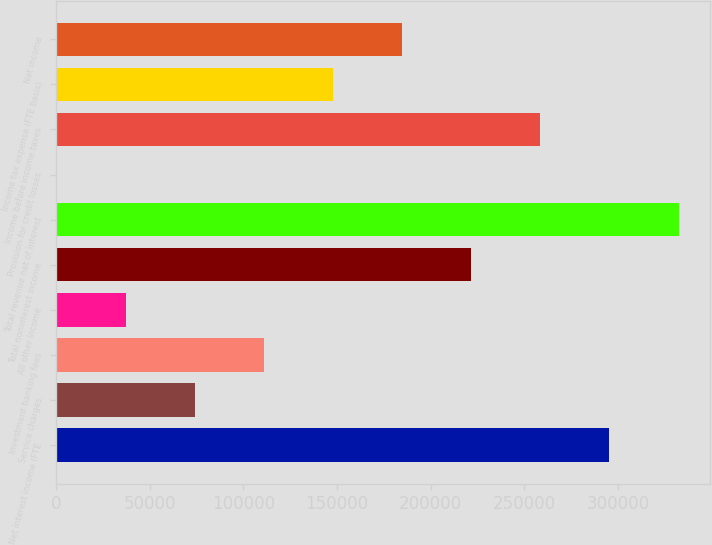<chart> <loc_0><loc_0><loc_500><loc_500><bar_chart><fcel>Net interest income (FTE<fcel>Service charges<fcel>Investment banking fees<fcel>All other income<fcel>Total noninterest income<fcel>Total revenue net of interest<fcel>Provision for credit losses<fcel>Income before income taxes<fcel>Income tax expense (FTE basis)<fcel>Net income<nl><fcel>295338<fcel>74349<fcel>111180<fcel>37517.5<fcel>221675<fcel>332170<fcel>686<fcel>258506<fcel>148012<fcel>184844<nl></chart> 